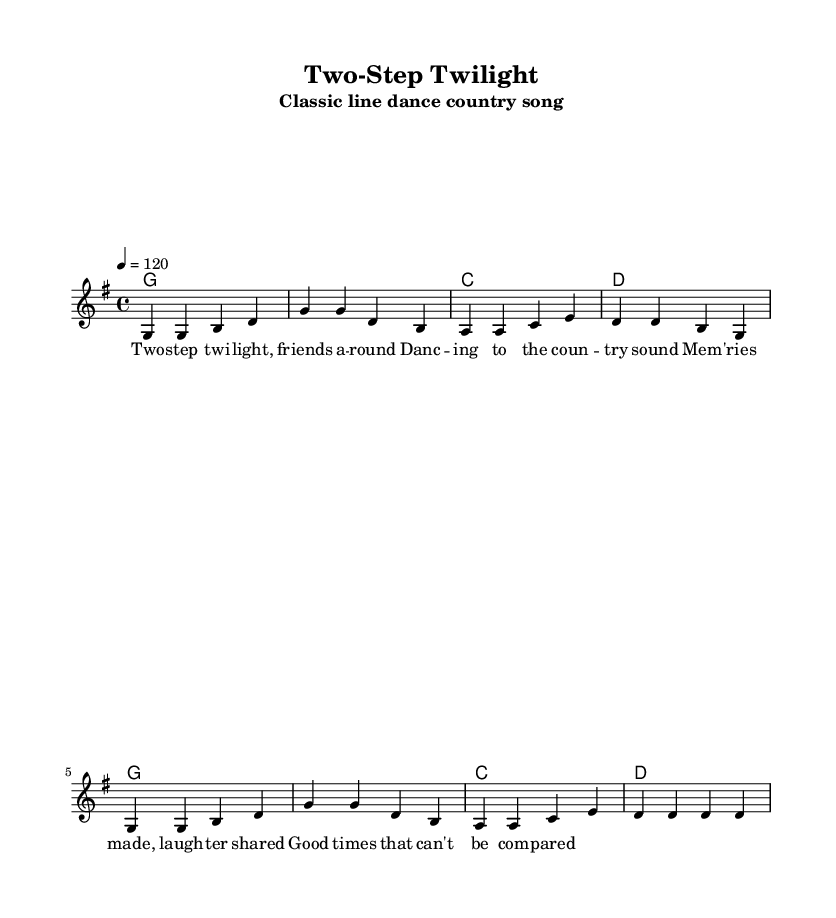What is the key signature of this music? The key signature is indicated at the beginning of the score. It shows one sharp, which indicates that the music is in G major.
Answer: G major What is the time signature of this piece? The time signature is displayed at the start of the score, indicating that there are four beats in each measure. This is represented as 4/4.
Answer: 4/4 What is the tempo marking for this piece? The tempo marking appears near the beginning of the score, showing a speed of 120 beats per minute. This means that the music should be played at a moderate pace.
Answer: 120 How many lines are in the melody? The melody consists of a single staff line shown in the score, which contains all the notes for the tune.
Answer: One line How many different chords are used in the harmonies section? The harmony section displays the chords that change throughout the piece. By examining the chords, we see there are four distinct chords: G, C, and D.
Answer: Three chords What type of song is "Two-Step Twilight"? The title and subtitle clearly indicate that this is a classic line dance country song, designed for group dancing.
Answer: Classic line dance country song 